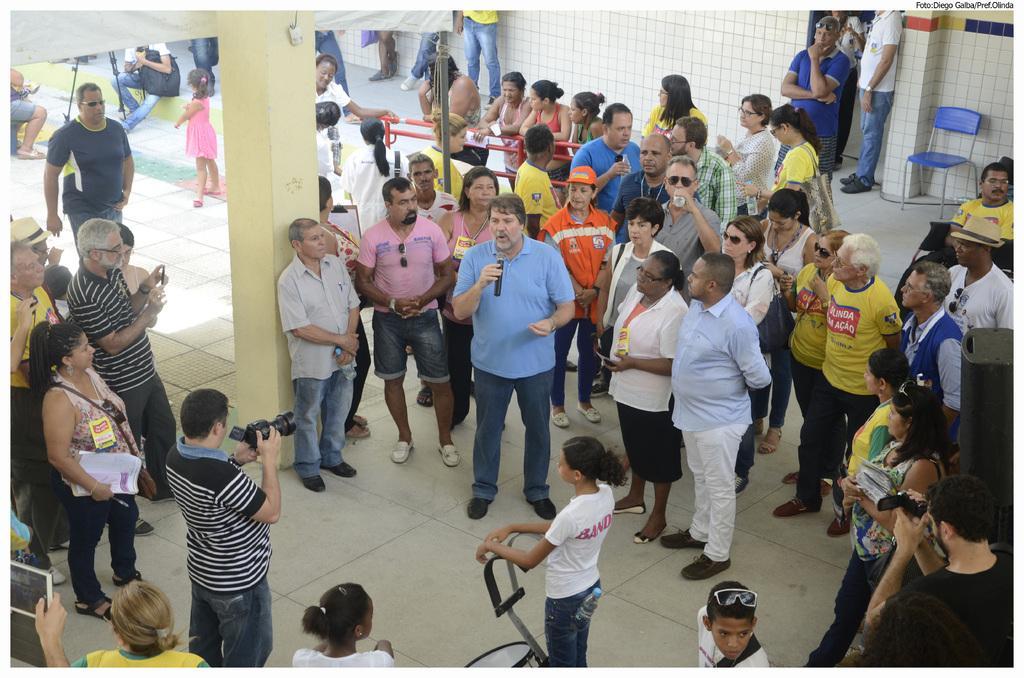How would you summarize this image in a sentence or two? In this image I see number of people in which this man is holding a mic and this man is holding a camera and I can also see few of them are holding electronic devices in their hands and I see the wall, a chair over here and I see the floor. 